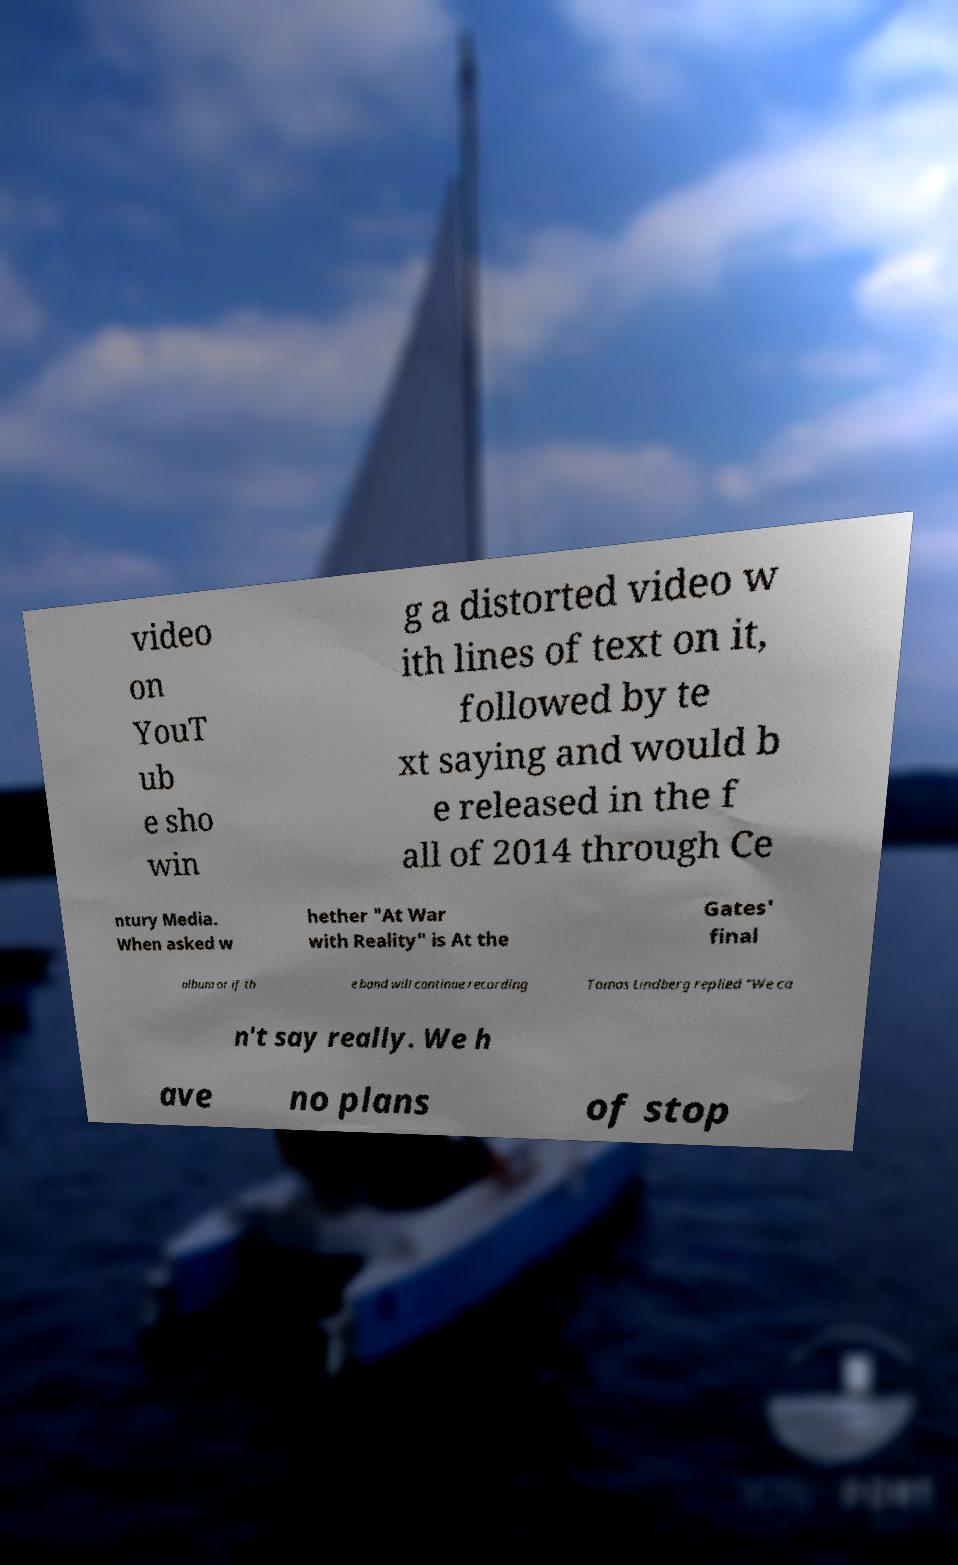Please identify and transcribe the text found in this image. video on YouT ub e sho win g a distorted video w ith lines of text on it, followed by te xt saying and would b e released in the f all of 2014 through Ce ntury Media. When asked w hether "At War with Reality" is At the Gates' final album or if th e band will continue recording Tomas Lindberg replied "We ca n't say really. We h ave no plans of stop 